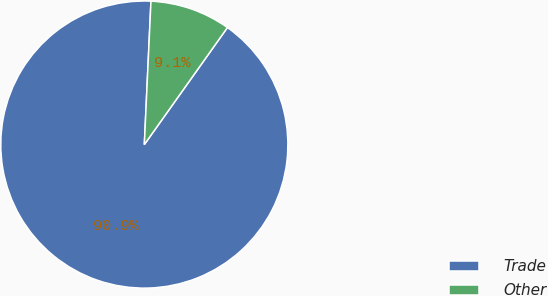<chart> <loc_0><loc_0><loc_500><loc_500><pie_chart><fcel>Trade<fcel>Other<nl><fcel>90.91%<fcel>9.09%<nl></chart> 